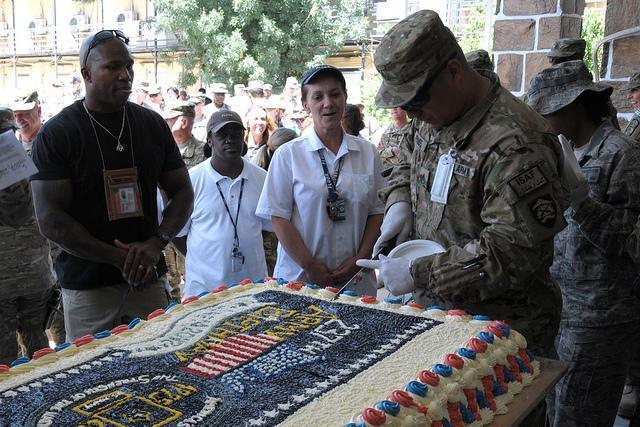How many people can you see?
Give a very brief answer. 6. 